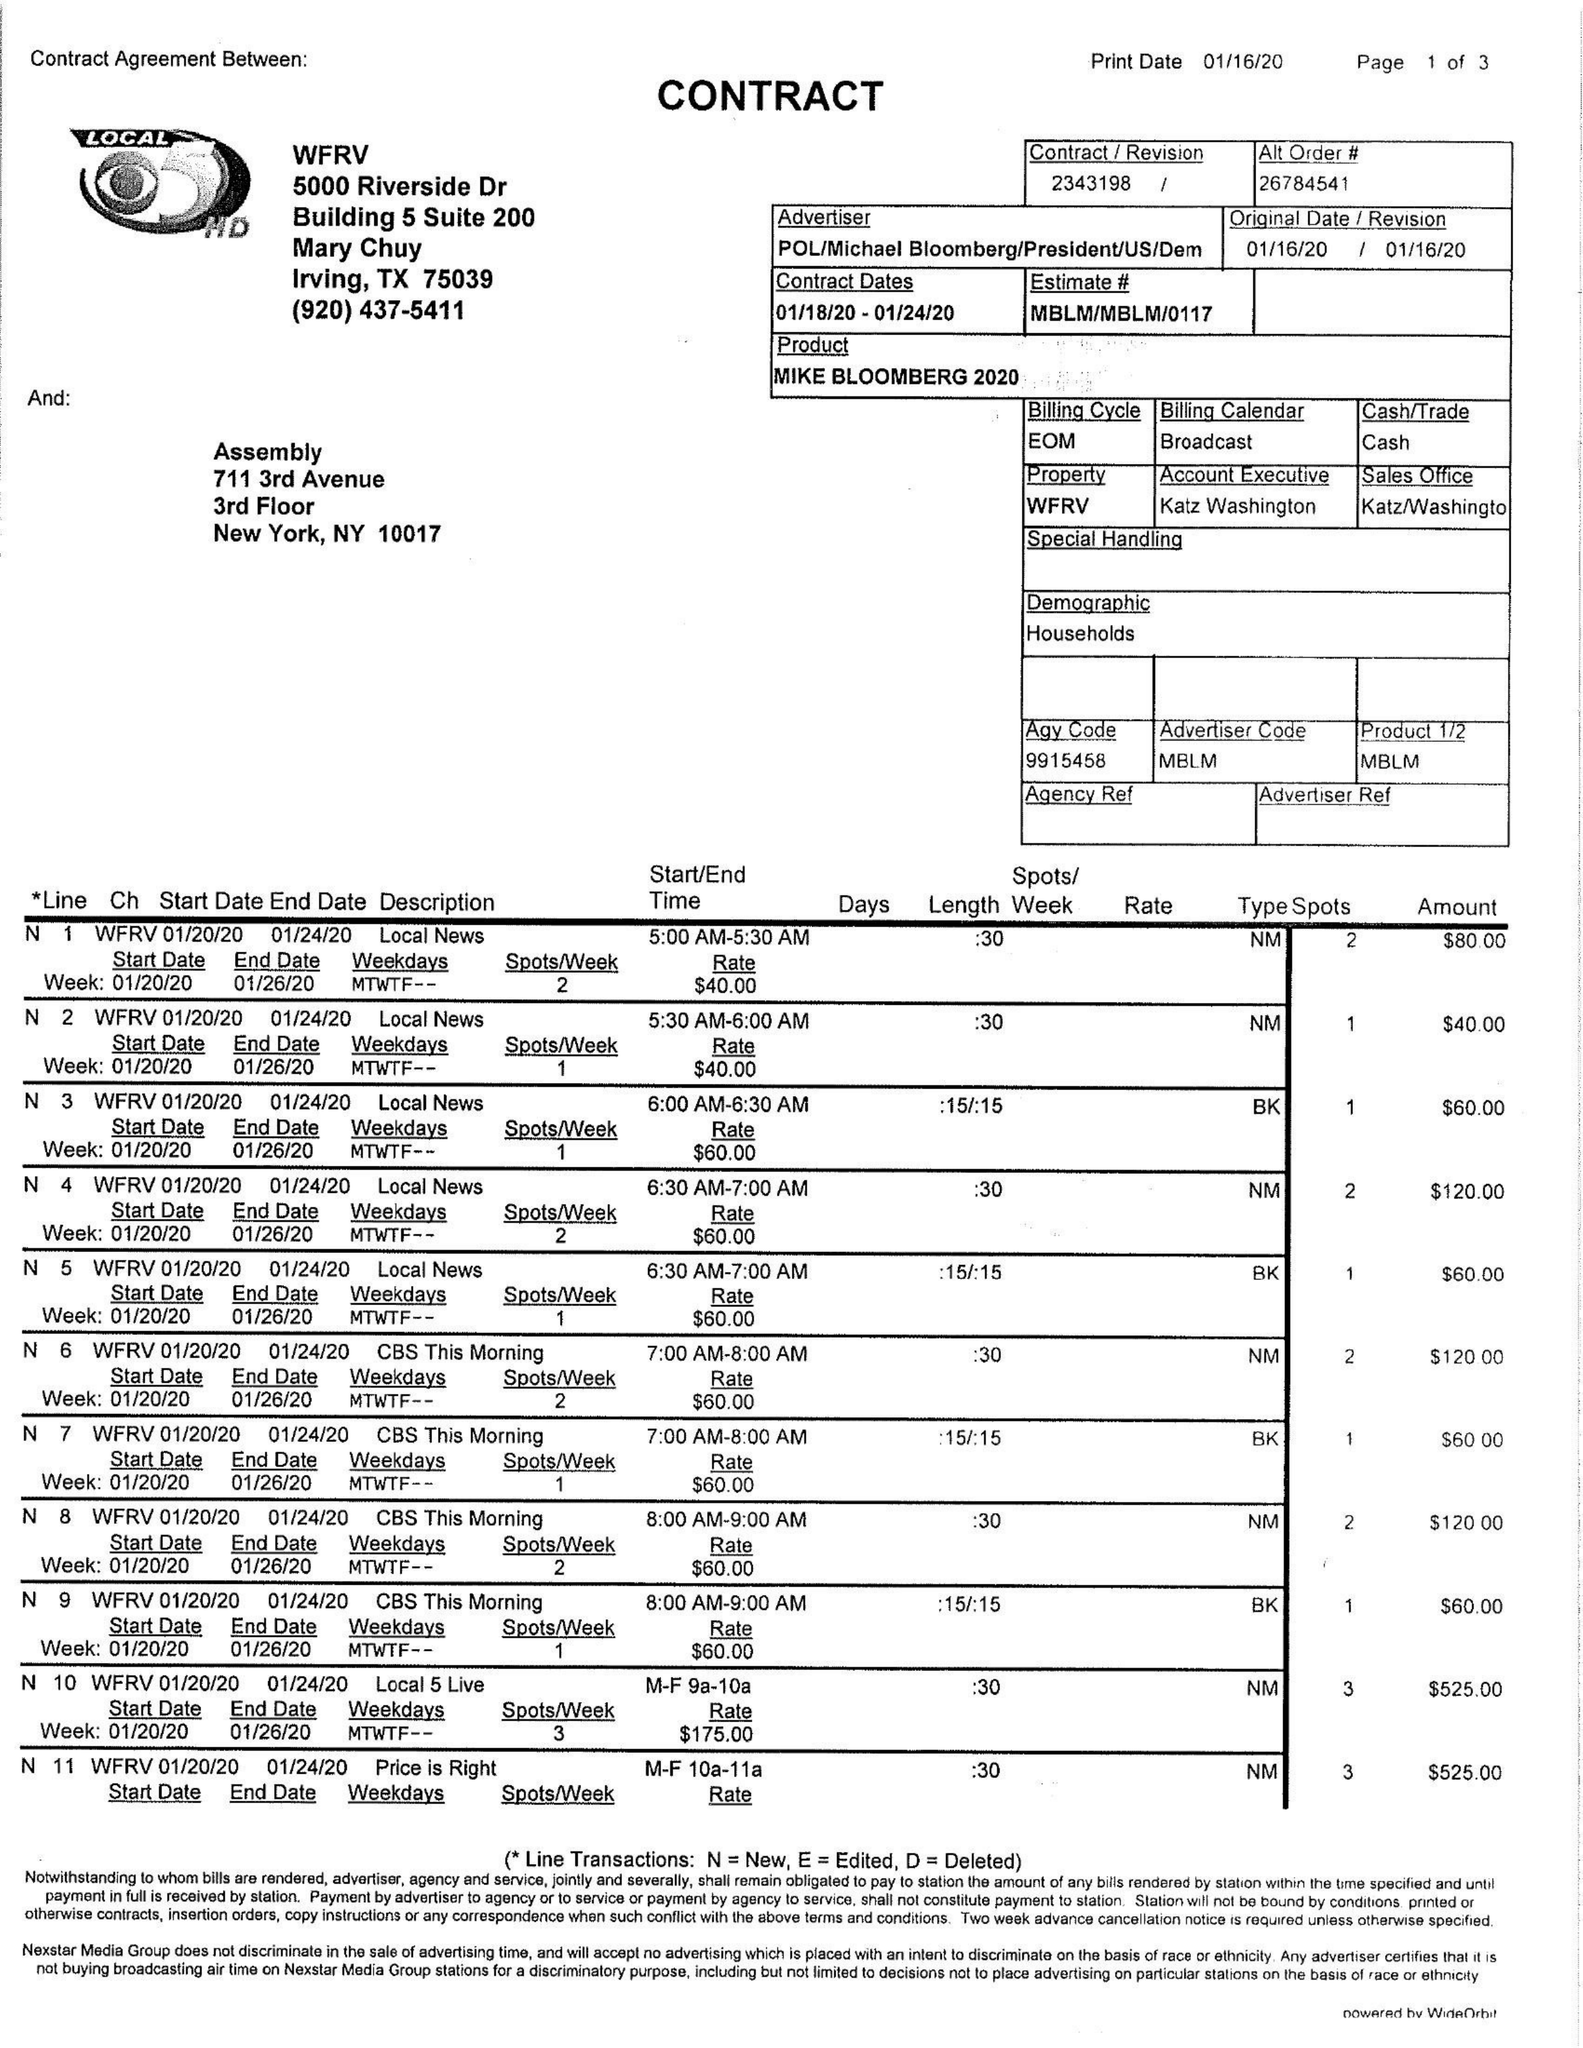What is the value for the flight_from?
Answer the question using a single word or phrase. 01/18/20 